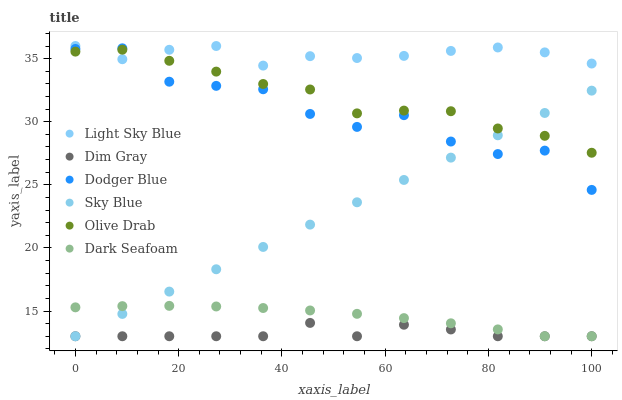Does Dim Gray have the minimum area under the curve?
Answer yes or no. Yes. Does Light Sky Blue have the maximum area under the curve?
Answer yes or no. Yes. Does Dark Seafoam have the minimum area under the curve?
Answer yes or no. No. Does Dark Seafoam have the maximum area under the curve?
Answer yes or no. No. Is Sky Blue the smoothest?
Answer yes or no. Yes. Is Dodger Blue the roughest?
Answer yes or no. Yes. Is Dark Seafoam the smoothest?
Answer yes or no. No. Is Dark Seafoam the roughest?
Answer yes or no. No. Does Dim Gray have the lowest value?
Answer yes or no. Yes. Does Light Sky Blue have the lowest value?
Answer yes or no. No. Does Light Sky Blue have the highest value?
Answer yes or no. Yes. Does Dark Seafoam have the highest value?
Answer yes or no. No. Is Sky Blue less than Light Sky Blue?
Answer yes or no. Yes. Is Dodger Blue greater than Dim Gray?
Answer yes or no. Yes. Does Dark Seafoam intersect Dim Gray?
Answer yes or no. Yes. Is Dark Seafoam less than Dim Gray?
Answer yes or no. No. Is Dark Seafoam greater than Dim Gray?
Answer yes or no. No. Does Sky Blue intersect Light Sky Blue?
Answer yes or no. No. 